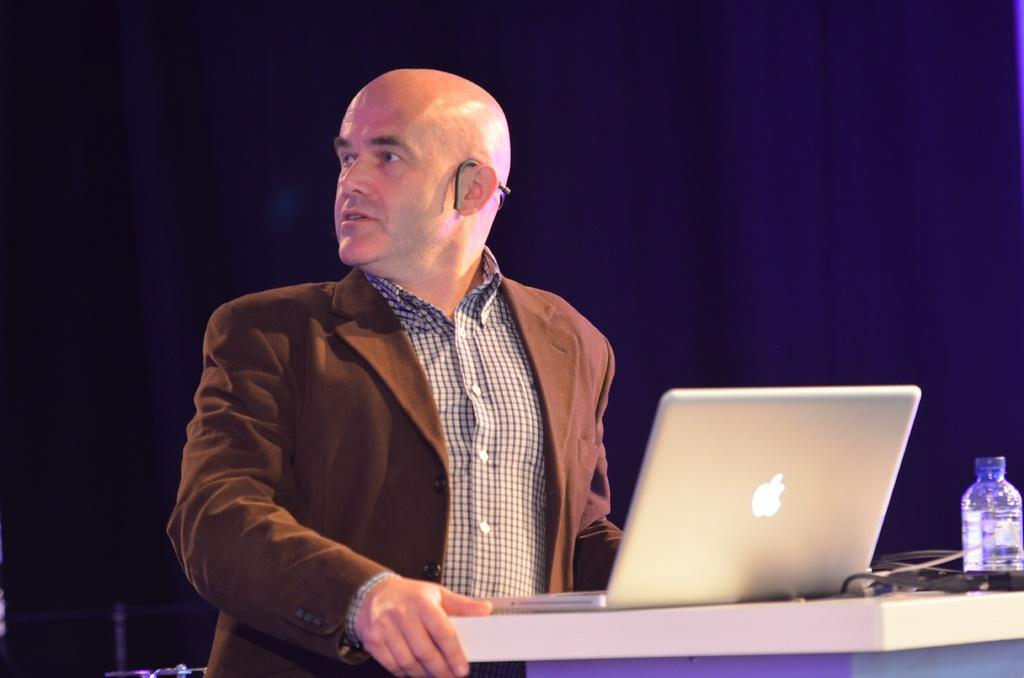Who is present in the image? There is a man in the image. What object is on the table in the image? There is a laptop and a bottle on the table in the image. What type of shock can be seen in the image? There is no shock present in the image. What is the distance between the man and the laptop in the image? The distance between the man and the laptop cannot be determined from the image alone, as there is no reference point for scale. 